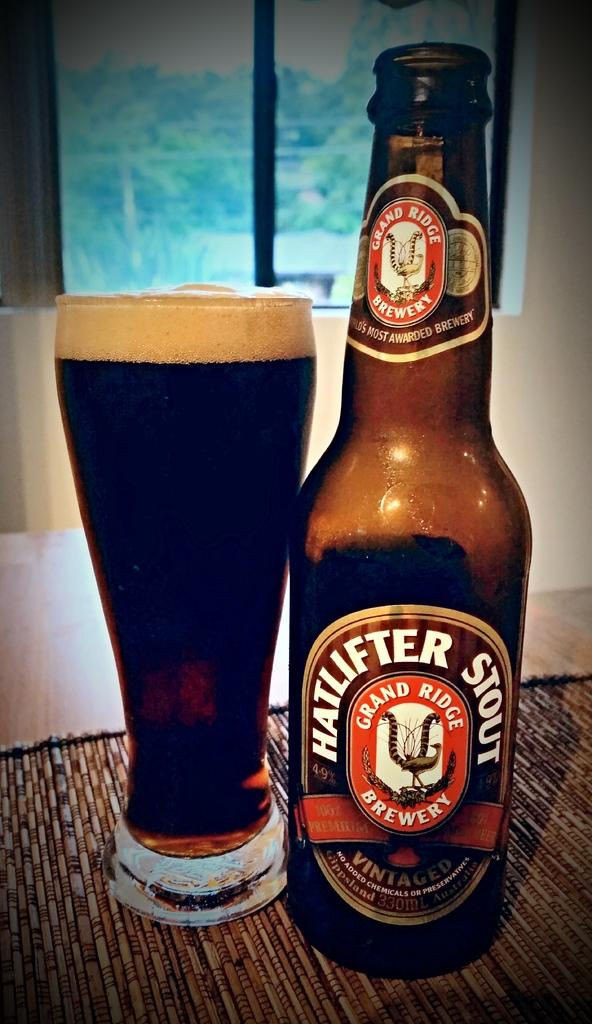Provide a one-sentence caption for the provided image. Hatlifter Stout Beer brewed from the Grand Ridge Brewery. 